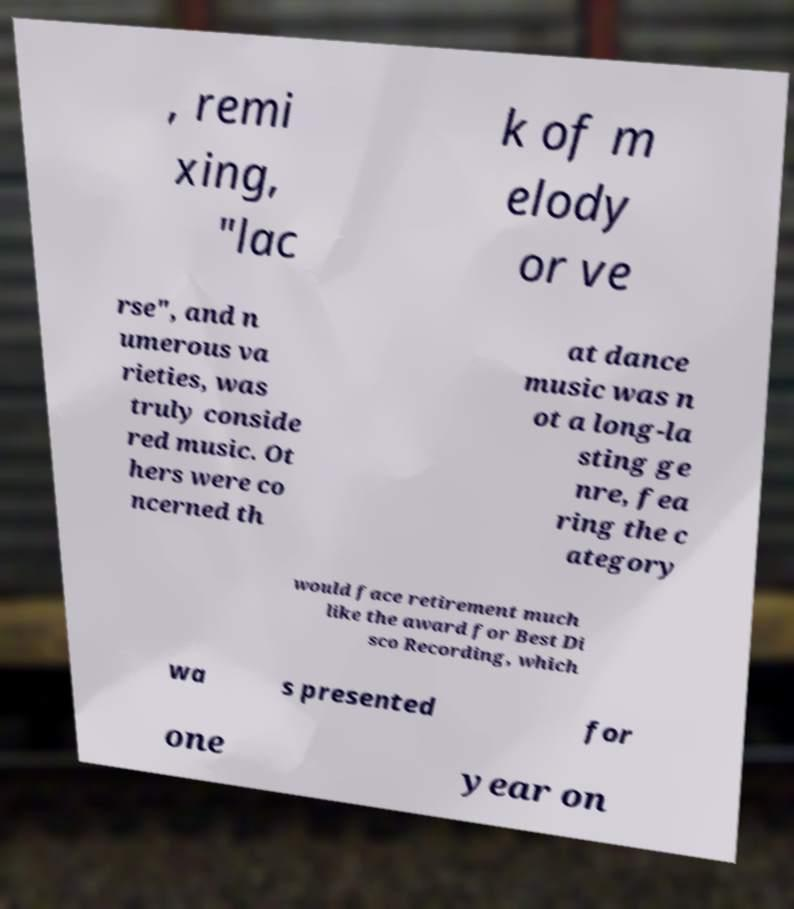Could you extract and type out the text from this image? , remi xing, "lac k of m elody or ve rse", and n umerous va rieties, was truly conside red music. Ot hers were co ncerned th at dance music was n ot a long-la sting ge nre, fea ring the c ategory would face retirement much like the award for Best Di sco Recording, which wa s presented for one year on 